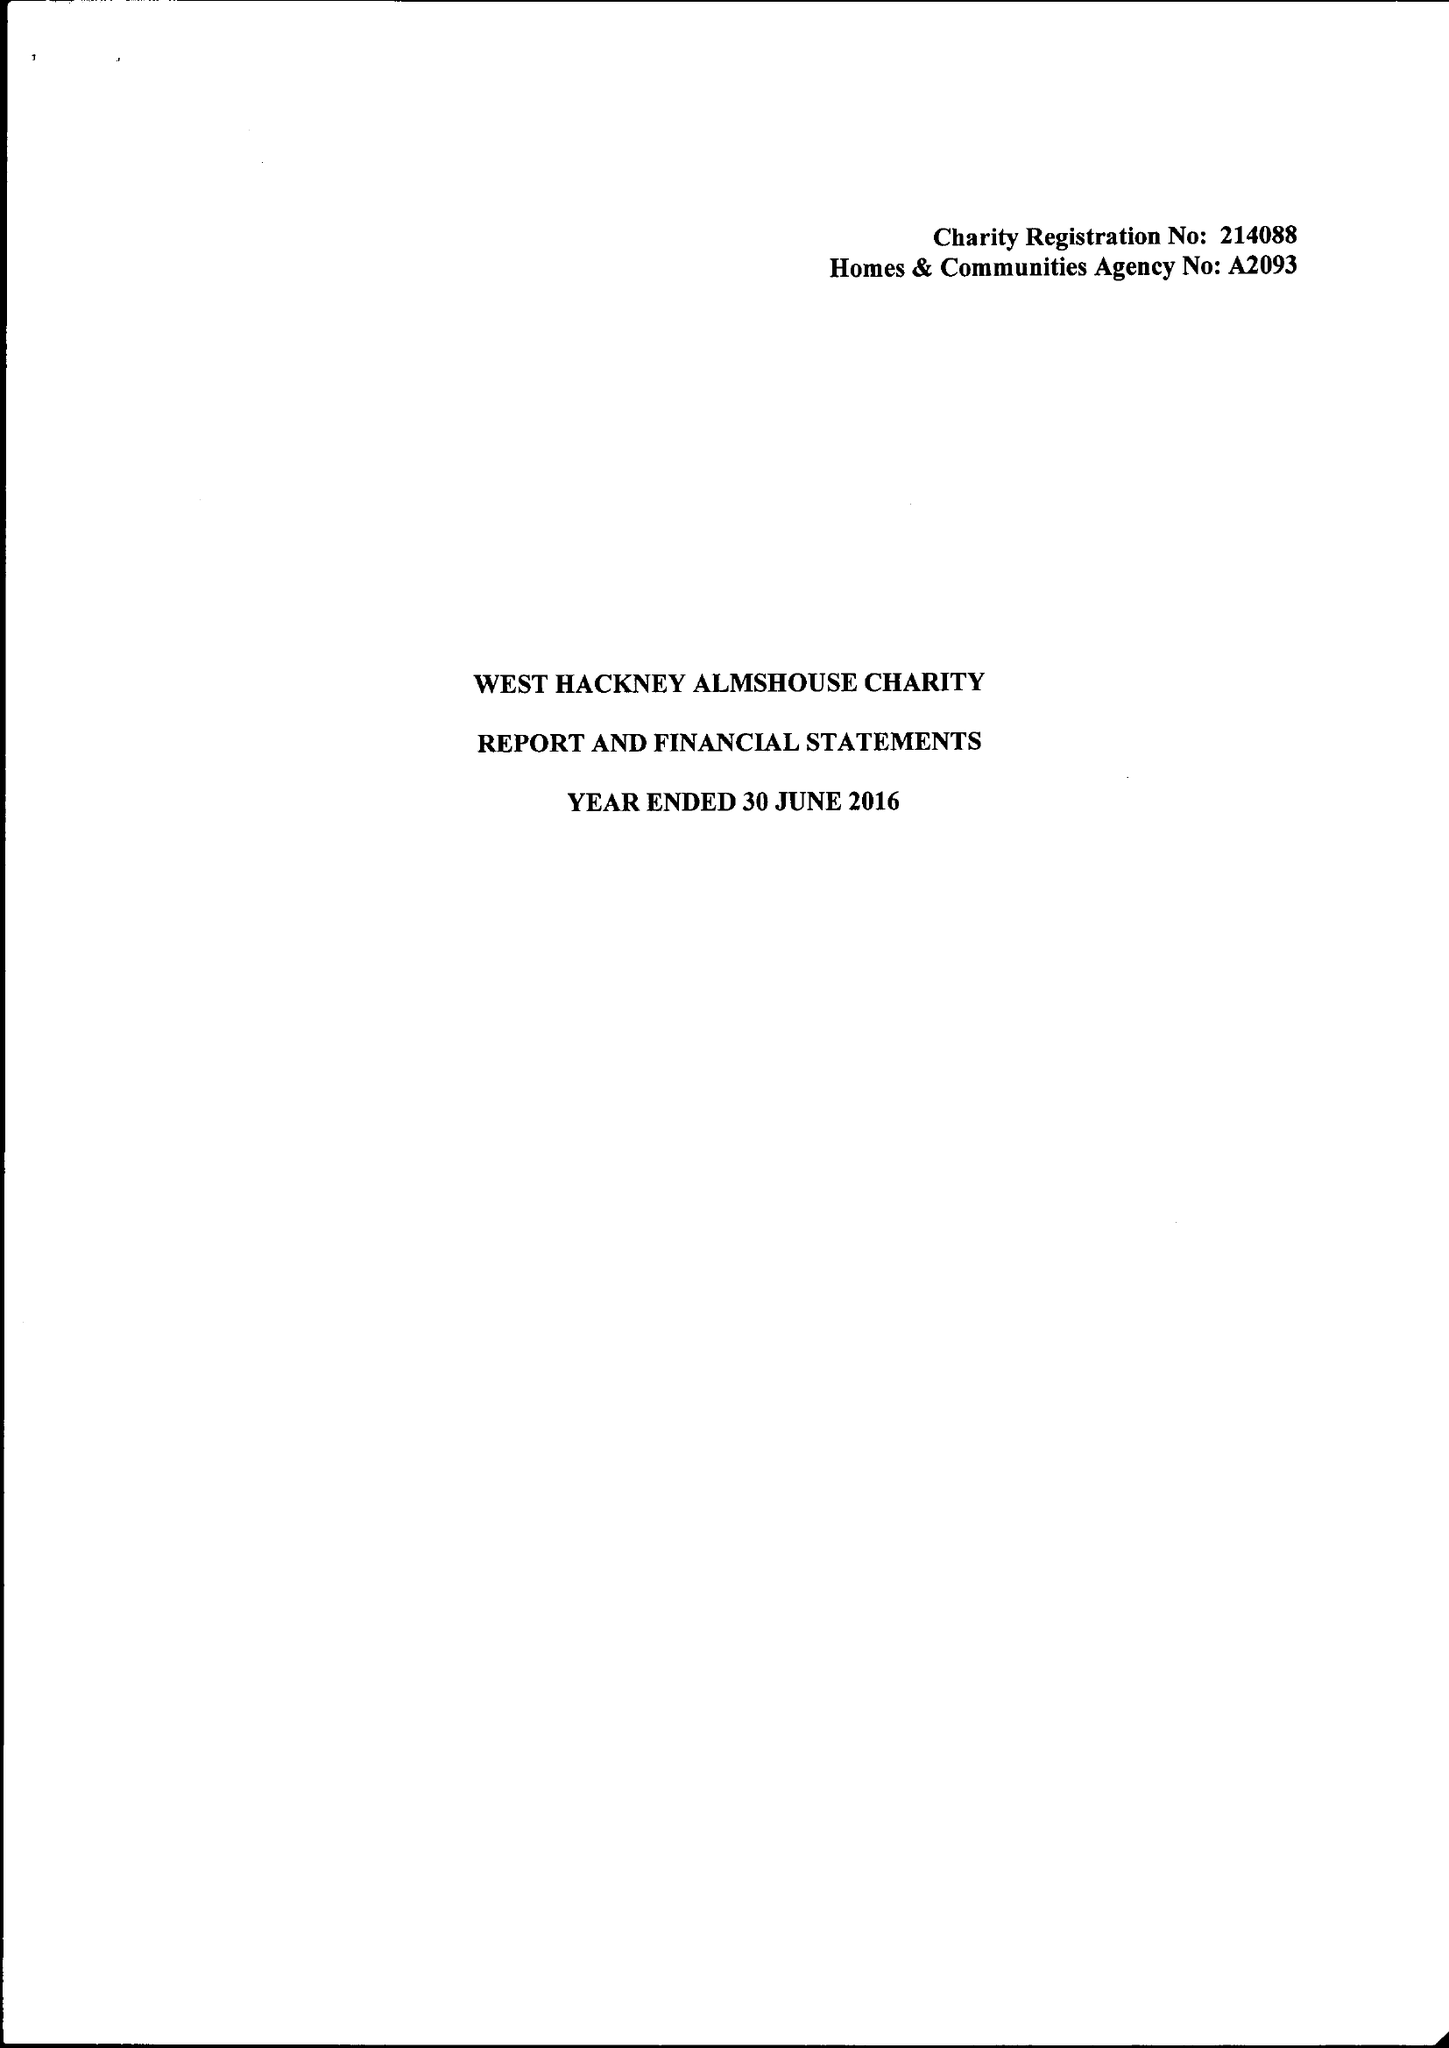What is the value for the charity_number?
Answer the question using a single word or phrase. 214088 